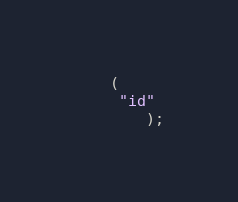<code> <loc_0><loc_0><loc_500><loc_500><_SQL_>    (
     "id"
        );





















</code> 